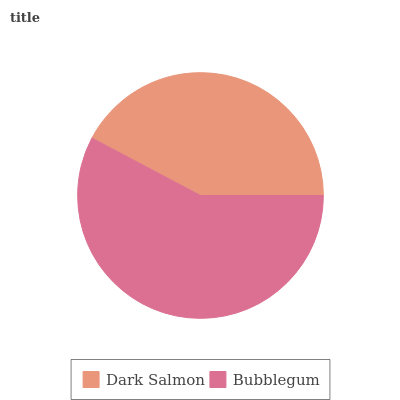Is Dark Salmon the minimum?
Answer yes or no. Yes. Is Bubblegum the maximum?
Answer yes or no. Yes. Is Bubblegum the minimum?
Answer yes or no. No. Is Bubblegum greater than Dark Salmon?
Answer yes or no. Yes. Is Dark Salmon less than Bubblegum?
Answer yes or no. Yes. Is Dark Salmon greater than Bubblegum?
Answer yes or no. No. Is Bubblegum less than Dark Salmon?
Answer yes or no. No. Is Bubblegum the high median?
Answer yes or no. Yes. Is Dark Salmon the low median?
Answer yes or no. Yes. Is Dark Salmon the high median?
Answer yes or no. No. Is Bubblegum the low median?
Answer yes or no. No. 